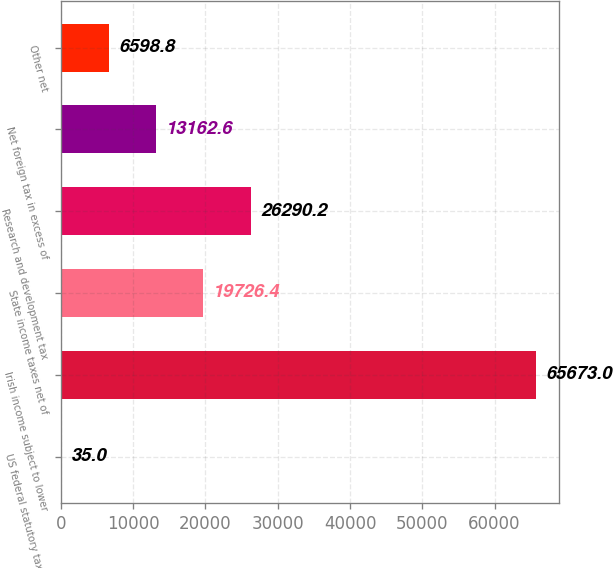Convert chart. <chart><loc_0><loc_0><loc_500><loc_500><bar_chart><fcel>US federal statutory tax rate<fcel>Irish income subject to lower<fcel>State income taxes net of<fcel>Research and development tax<fcel>Net foreign tax in excess of<fcel>Other net<nl><fcel>35<fcel>65673<fcel>19726.4<fcel>26290.2<fcel>13162.6<fcel>6598.8<nl></chart> 